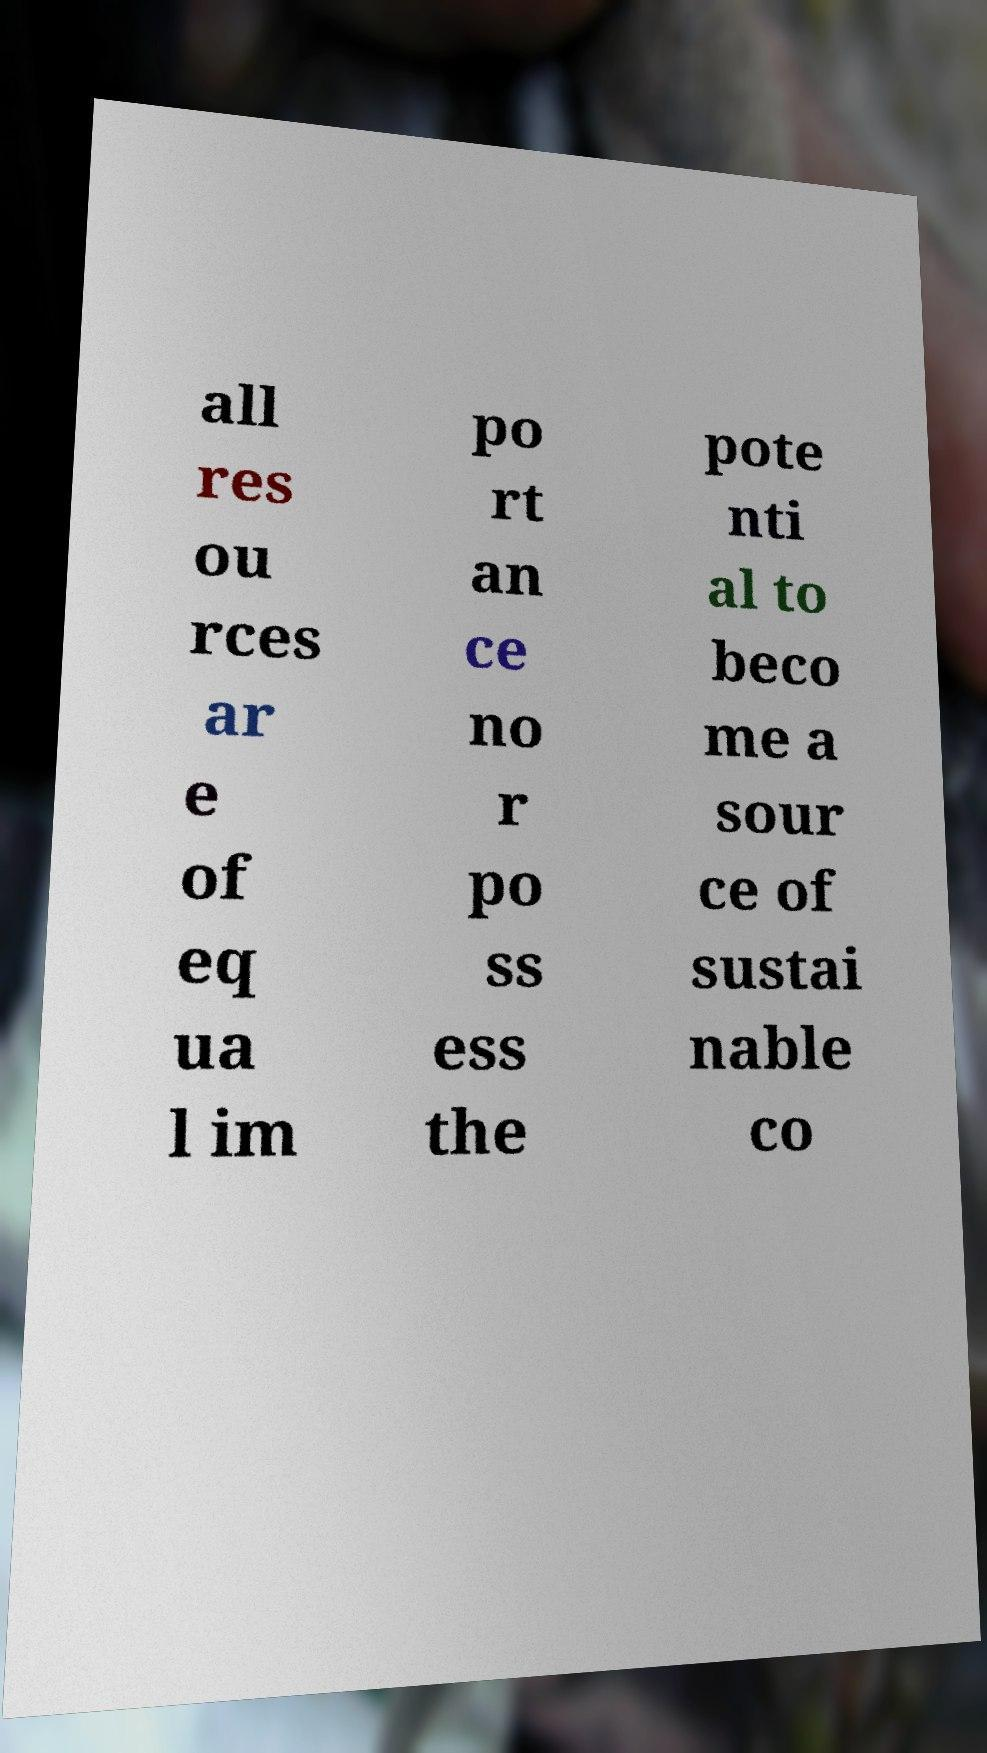I need the written content from this picture converted into text. Can you do that? all res ou rces ar e of eq ua l im po rt an ce no r po ss ess the pote nti al to beco me a sour ce of sustai nable co 